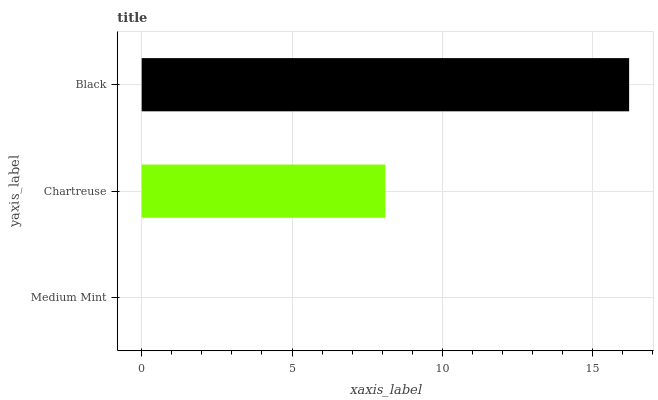Is Medium Mint the minimum?
Answer yes or no. Yes. Is Black the maximum?
Answer yes or no. Yes. Is Chartreuse the minimum?
Answer yes or no. No. Is Chartreuse the maximum?
Answer yes or no. No. Is Chartreuse greater than Medium Mint?
Answer yes or no. Yes. Is Medium Mint less than Chartreuse?
Answer yes or no. Yes. Is Medium Mint greater than Chartreuse?
Answer yes or no. No. Is Chartreuse less than Medium Mint?
Answer yes or no. No. Is Chartreuse the high median?
Answer yes or no. Yes. Is Chartreuse the low median?
Answer yes or no. Yes. Is Black the high median?
Answer yes or no. No. Is Medium Mint the low median?
Answer yes or no. No. 